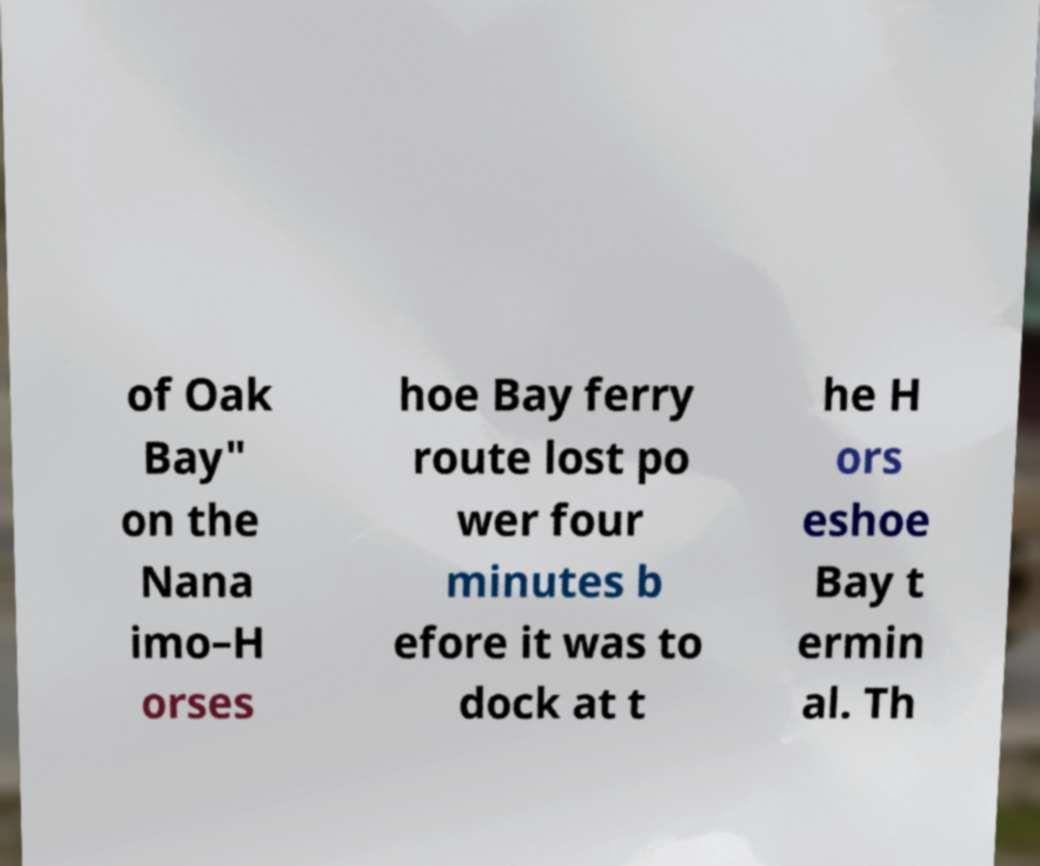For documentation purposes, I need the text within this image transcribed. Could you provide that? of Oak Bay" on the Nana imo–H orses hoe Bay ferry route lost po wer four minutes b efore it was to dock at t he H ors eshoe Bay t ermin al. Th 